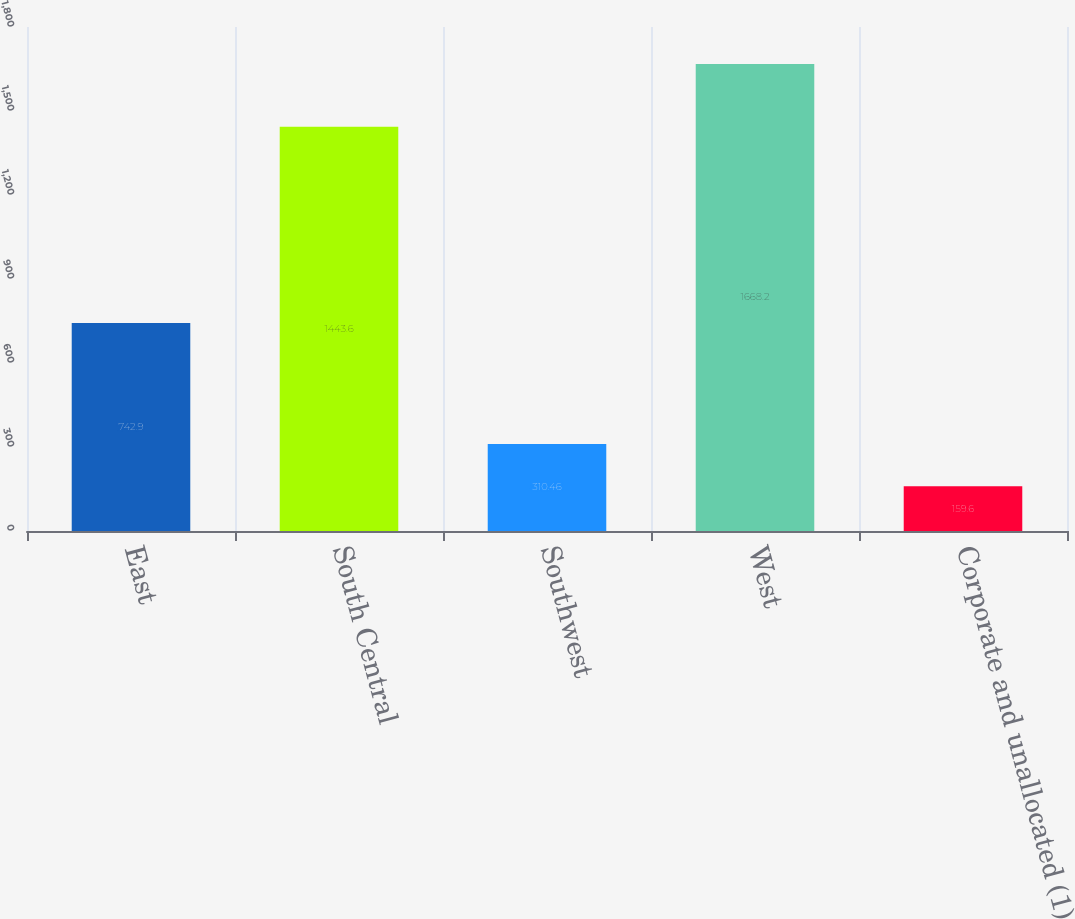Convert chart. <chart><loc_0><loc_0><loc_500><loc_500><bar_chart><fcel>East<fcel>South Central<fcel>Southwest<fcel>West<fcel>Corporate and unallocated (1)<nl><fcel>742.9<fcel>1443.6<fcel>310.46<fcel>1668.2<fcel>159.6<nl></chart> 